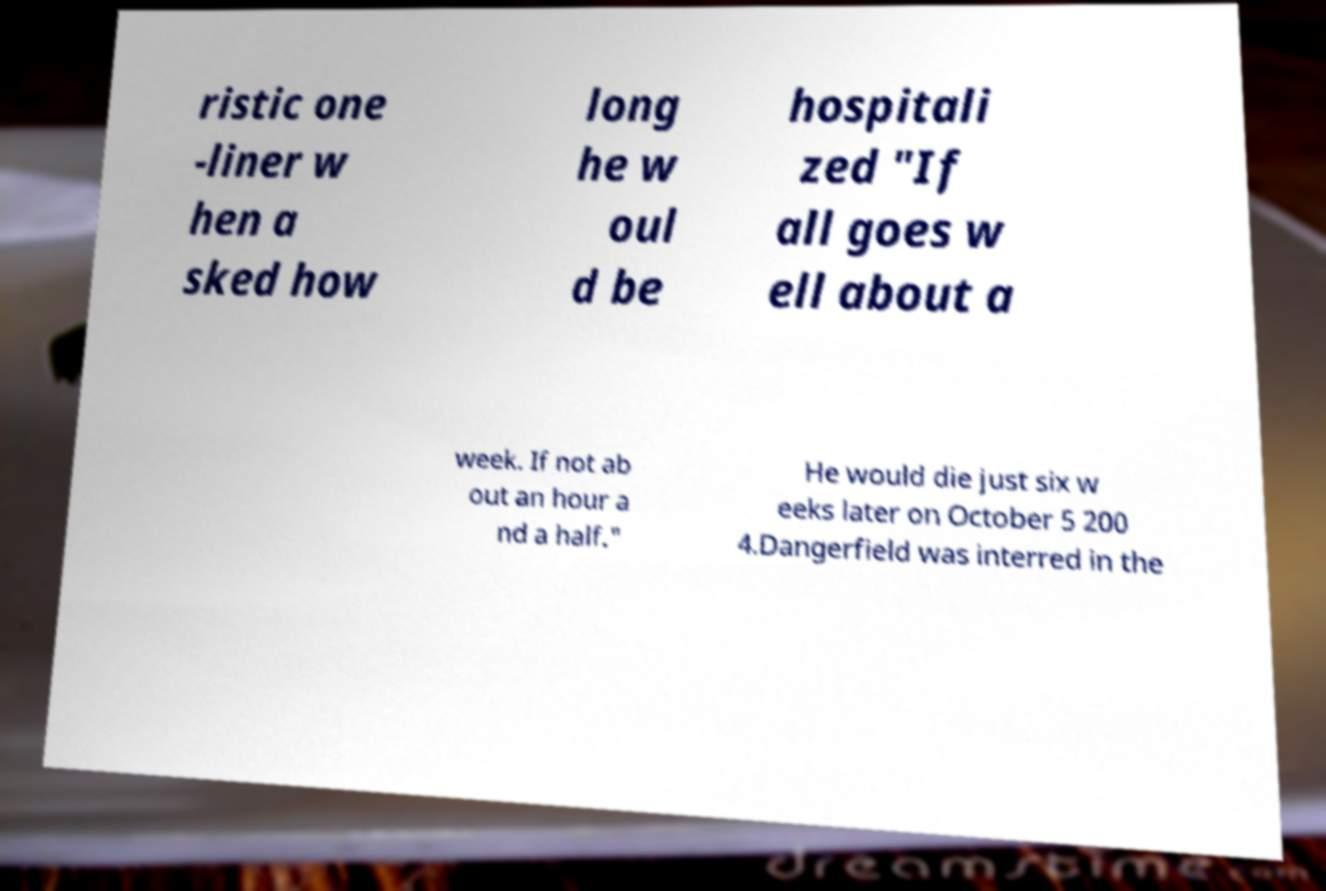For documentation purposes, I need the text within this image transcribed. Could you provide that? ristic one -liner w hen a sked how long he w oul d be hospitali zed "If all goes w ell about a week. If not ab out an hour a nd a half." He would die just six w eeks later on October 5 200 4.Dangerfield was interred in the 